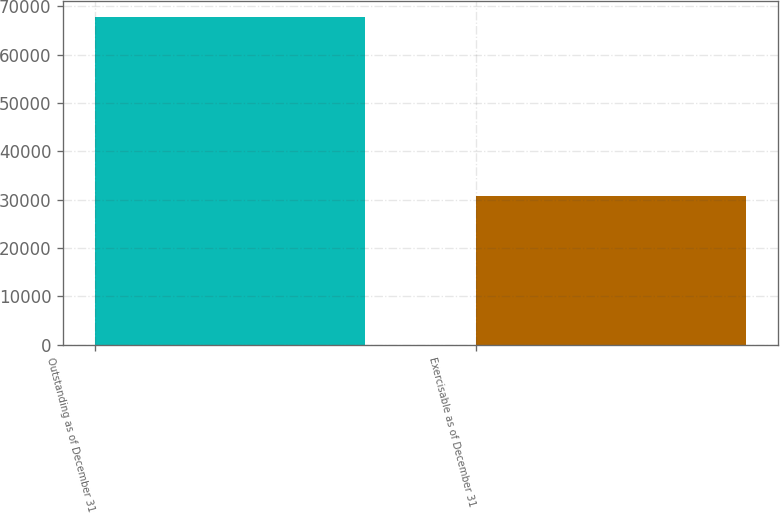<chart> <loc_0><loc_0><loc_500><loc_500><bar_chart><fcel>Outstanding as of December 31<fcel>Exercisable as of December 31<nl><fcel>67740<fcel>30723.9<nl></chart> 